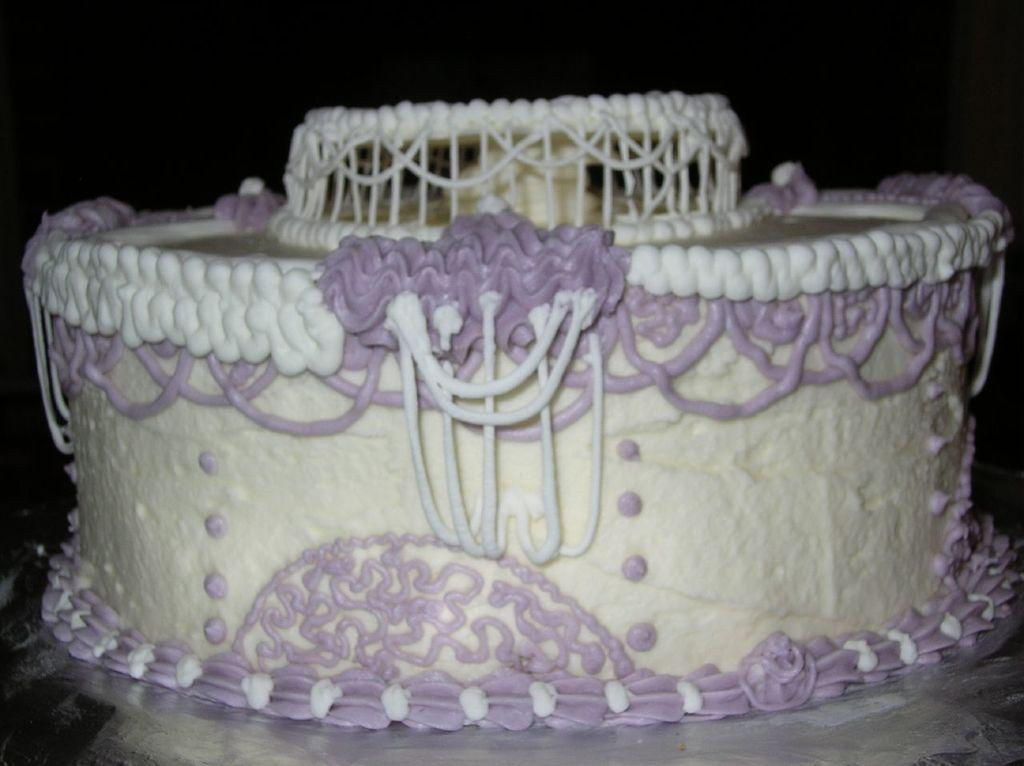What is the main subject of the image? The main subject of the image is a cake. Where is the cake located in the image? The cake is on a platform. What can be observed about the background of the image? The background of the image is dark. Can you see a kitten pulling the cake on the platform in the image? No, there is no kitten or any indication of pulling in the image. The image only features a cake on a platform with a dark background. 